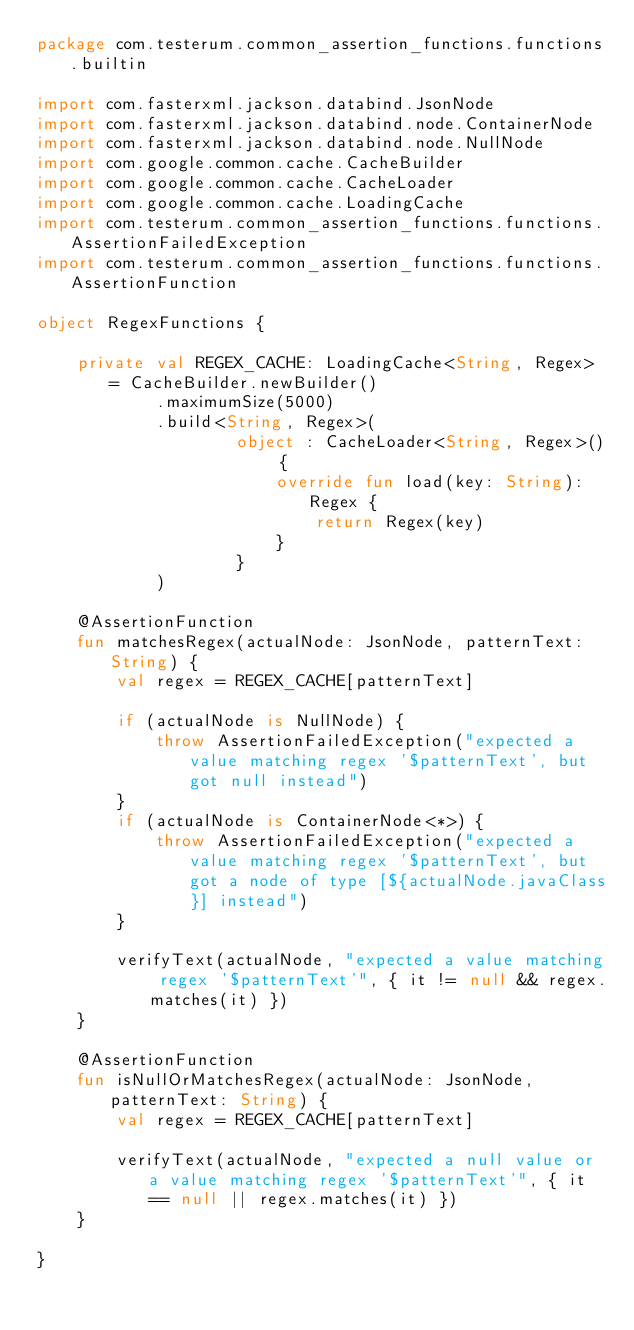Convert code to text. <code><loc_0><loc_0><loc_500><loc_500><_Kotlin_>package com.testerum.common_assertion_functions.functions.builtin

import com.fasterxml.jackson.databind.JsonNode
import com.fasterxml.jackson.databind.node.ContainerNode
import com.fasterxml.jackson.databind.node.NullNode
import com.google.common.cache.CacheBuilder
import com.google.common.cache.CacheLoader
import com.google.common.cache.LoadingCache
import com.testerum.common_assertion_functions.functions.AssertionFailedException
import com.testerum.common_assertion_functions.functions.AssertionFunction

object RegexFunctions {

    private val REGEX_CACHE: LoadingCache<String, Regex> = CacheBuilder.newBuilder()
            .maximumSize(5000)
            .build<String, Regex>(
                    object : CacheLoader<String, Regex>() {
                        override fun load(key: String): Regex {
                            return Regex(key)
                        }
                    }
            )

    @AssertionFunction
    fun matchesRegex(actualNode: JsonNode, patternText: String) {
        val regex = REGEX_CACHE[patternText]

        if (actualNode is NullNode) {
            throw AssertionFailedException("expected a value matching regex '$patternText', but got null instead")
        }
        if (actualNode is ContainerNode<*>) {
            throw AssertionFailedException("expected a value matching regex '$patternText', but got a node of type [${actualNode.javaClass}] instead")
        }

        verifyText(actualNode, "expected a value matching regex '$patternText'", { it != null && regex.matches(it) })
    }

    @AssertionFunction
    fun isNullOrMatchesRegex(actualNode: JsonNode, patternText: String) {
        val regex = REGEX_CACHE[patternText]

        verifyText(actualNode, "expected a null value or a value matching regex '$patternText'", { it == null || regex.matches(it) })
    }

}</code> 